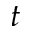<formula> <loc_0><loc_0><loc_500><loc_500>t</formula> 